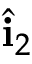Convert formula to latex. <formula><loc_0><loc_0><loc_500><loc_500>\hat { i } _ { 2 }</formula> 